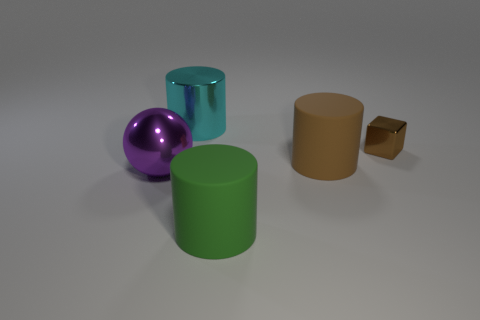Subtract all metallic cylinders. How many cylinders are left? 2 Add 5 big cyan objects. How many objects exist? 10 Subtract all spheres. How many objects are left? 4 Subtract all gray metallic objects. Subtract all small brown objects. How many objects are left? 4 Add 5 metal objects. How many metal objects are left? 8 Add 2 small red metallic cubes. How many small red metallic cubes exist? 2 Subtract 0 red balls. How many objects are left? 5 Subtract all yellow cylinders. Subtract all gray blocks. How many cylinders are left? 3 